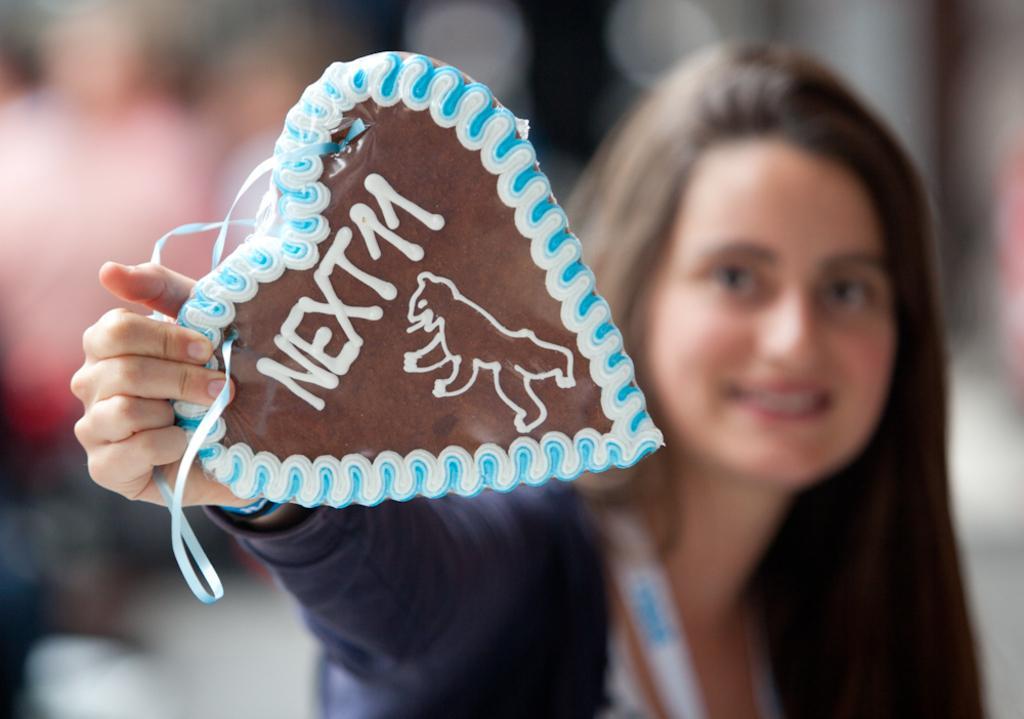In one or two sentences, can you explain what this image depicts? In this picture we can see a person holding a heart shaped object in hand and smiling. Background is blurry. 